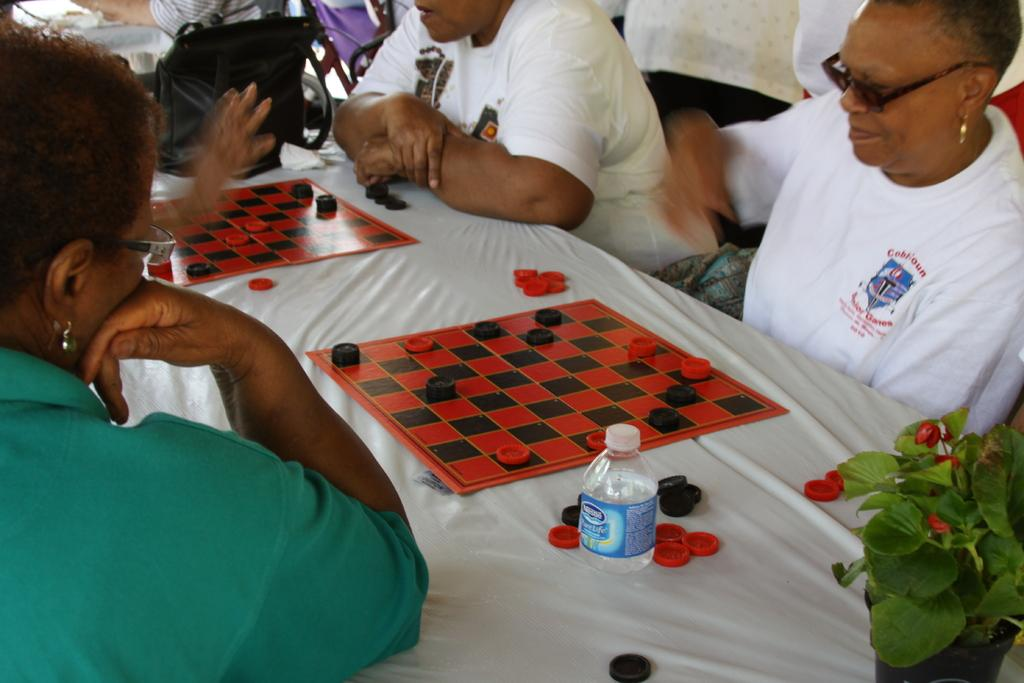What is the main piece of furniture in the image? There is a table in the image. Who is present around the table? There are people sitting at the table. What is placed on the table along with the people? There is a bottle, a plant, coins, and a chess board. What type of advice can be seen written on the rose in the image? There is no rose present in the image, so no advice can be seen written on it. 